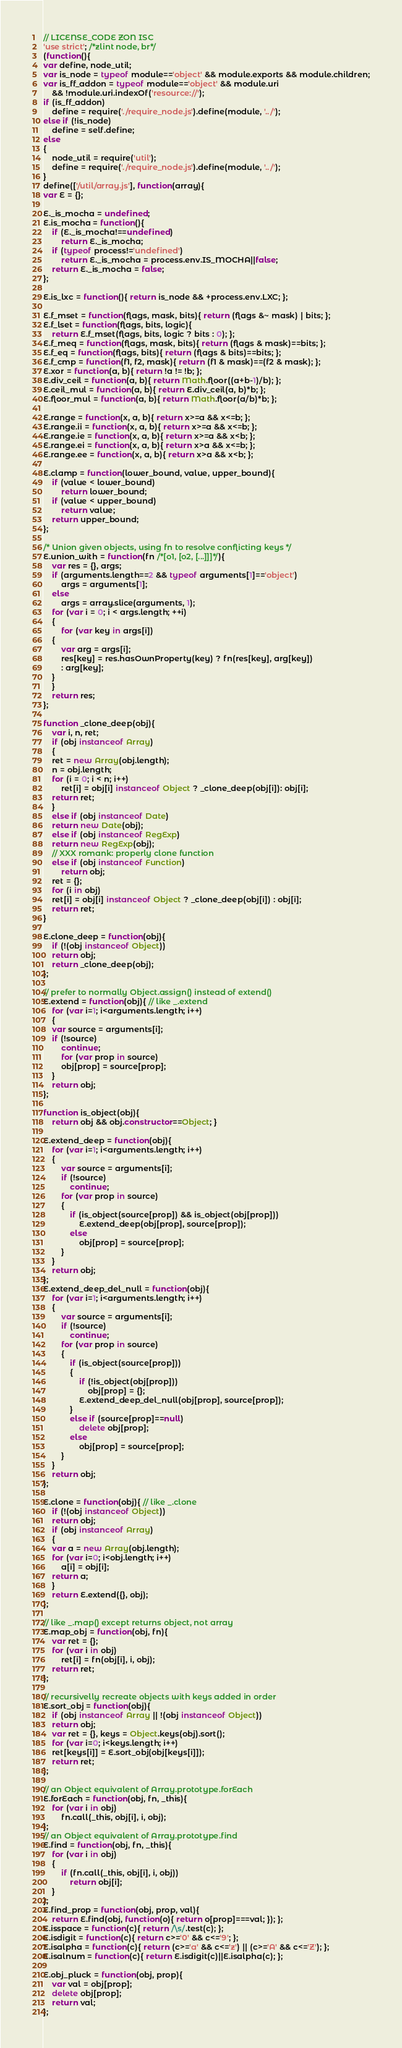<code> <loc_0><loc_0><loc_500><loc_500><_JavaScript_>// LICENSE_CODE ZON ISC
'use strict'; /*zlint node, br*/
(function(){
var define, node_util;
var is_node = typeof module=='object' && module.exports && module.children;
var is_ff_addon = typeof module=='object' && module.uri
    && !module.uri.indexOf('resource://');
if (is_ff_addon)
    define = require('./require_node.js').define(module, '../');
else if (!is_node)
    define = self.define;
else
{
    node_util = require('util');
    define = require('./require_node.js').define(module, '../');
}
define(['/util/array.js'], function(array){
var E = {};

E._is_mocha = undefined;
E.is_mocha = function(){
    if (E._is_mocha!==undefined)
        return E._is_mocha;
    if (typeof process!='undefined')
        return E._is_mocha = process.env.IS_MOCHA||false;
    return E._is_mocha = false;
};

E.is_lxc = function(){ return is_node && +process.env.LXC; };

E.f_mset = function(flags, mask, bits){ return (flags &~ mask) | bits; };
E.f_lset = function(flags, bits, logic){
    return E.f_mset(flags, bits, logic ? bits : 0); };
E.f_meq = function(flags, mask, bits){ return (flags & mask)==bits; };
E.f_eq = function(flags, bits){ return (flags & bits)==bits; };
E.f_cmp = function(f1, f2, mask){ return (f1 & mask)==(f2 & mask); };
E.xor = function(a, b){ return !a != !b; };
E.div_ceil = function(a, b){ return Math.floor((a+b-1)/b); };
E.ceil_mul = function(a, b){ return E.div_ceil(a, b)*b; };
E.floor_mul = function(a, b){ return Math.floor(a/b)*b; };

E.range = function(x, a, b){ return x>=a && x<=b; };
E.range.ii = function(x, a, b){ return x>=a && x<=b; };
E.range.ie = function(x, a, b){ return x>=a && x<b; };
E.range.ei = function(x, a, b){ return x>a && x<=b; };
E.range.ee = function(x, a, b){ return x>a && x<b; };

E.clamp = function(lower_bound, value, upper_bound){
    if (value < lower_bound)
        return lower_bound;
    if (value < upper_bound)
        return value;
    return upper_bound;
};

/* Union given objects, using fn to resolve conflicting keys */
E.union_with = function(fn /*[o1, [o2, [...]]]*/){
    var res = {}, args;
    if (arguments.length==2 && typeof arguments[1]=='object')
        args = arguments[1];
    else
        args = array.slice(arguments, 1);
    for (var i = 0; i < args.length; ++i)
    {
        for (var key in args[i])
	{
	    var arg = args[i];
	    res[key] = res.hasOwnProperty(key) ? fn(res[key], arg[key])
		: arg[key];
	}
    }
    return res;
};

function _clone_deep(obj){
    var i, n, ret;
    if (obj instanceof Array)
    {
	ret = new Array(obj.length);
	n = obj.length;
	for (i = 0; i < n; i++)
	    ret[i] = obj[i] instanceof Object ? _clone_deep(obj[i]): obj[i];
	return ret;
    }
    else if (obj instanceof Date)
	return new Date(obj);
    else if (obj instanceof RegExp)
	return new RegExp(obj);
    // XXX romank: properly clone function
    else if (obj instanceof Function)
        return obj;
    ret = {};
    for (i in obj)
	ret[i] = obj[i] instanceof Object ? _clone_deep(obj[i]) : obj[i];
    return ret;
}

E.clone_deep = function(obj){
    if (!(obj instanceof Object))
	return obj;
    return _clone_deep(obj);
};

// prefer to normally Object.assign() instead of extend()
E.extend = function(obj){ // like _.extend
    for (var i=1; i<arguments.length; i++)
    {
	var source = arguments[i];
	if (!source)
	    continue;
        for (var prop in source)
	    obj[prop] = source[prop];
    }
    return obj;
};

function is_object(obj){
    return obj && obj.constructor==Object; }

E.extend_deep = function(obj){
    for (var i=1; i<arguments.length; i++)
    {
        var source = arguments[i];
        if (!source)
            continue;
        for (var prop in source)
        {
            if (is_object(source[prop]) && is_object(obj[prop]))
                E.extend_deep(obj[prop], source[prop]);
            else
                obj[prop] = source[prop];
        }
    }
    return obj;
};
E.extend_deep_del_null = function(obj){
    for (var i=1; i<arguments.length; i++)
    {
        var source = arguments[i];
        if (!source)
            continue;
        for (var prop in source)
        {
            if (is_object(source[prop]))
            {
                if (!is_object(obj[prop]))
                    obj[prop] = {};
                E.extend_deep_del_null(obj[prop], source[prop]);
            }
            else if (source[prop]==null)
                delete obj[prop];
            else
                obj[prop] = source[prop];
        }
    }
    return obj;
};

E.clone = function(obj){ // like _.clone
    if (!(obj instanceof Object))
	return obj;
    if (obj instanceof Array)
    {
	var a = new Array(obj.length);
	for (var i=0; i<obj.length; i++)
	    a[i] = obj[i];
	return a;
    }
    return E.extend({}, obj);
};

// like _.map() except returns object, not array
E.map_obj = function(obj, fn){
    var ret = {};
    for (var i in obj)
        ret[i] = fn(obj[i], i, obj);
    return ret;
};

// recursivelly recreate objects with keys added in order
E.sort_obj = function(obj){
    if (obj instanceof Array || !(obj instanceof Object))
	return obj;
    var ret = {}, keys = Object.keys(obj).sort();
    for (var i=0; i<keys.length; i++)
	ret[keys[i]] = E.sort_obj(obj[keys[i]]);
    return ret;
};

// an Object equivalent of Array.prototype.forEach
E.forEach = function(obj, fn, _this){
    for (var i in obj)
        fn.call(_this, obj[i], i, obj);
};
// an Object equivalent of Array.prototype.find
E.find = function(obj, fn, _this){
    for (var i in obj)
    {
        if (fn.call(_this, obj[i], i, obj))
            return obj[i];
    }
};
E.find_prop = function(obj, prop, val){
    return E.find(obj, function(o){ return o[prop]===val; }); };
E.isspace = function(c){ return /\s/.test(c); };
E.isdigit = function(c){ return c>='0' && c<='9'; };
E.isalpha = function(c){ return (c>='a' && c<='z') || (c>='A' && c<='Z'); };
E.isalnum = function(c){ return E.isdigit(c)||E.isalpha(c); };

E.obj_pluck = function(obj, prop){
    var val = obj[prop];
    delete obj[prop];
    return val;
};
</code> 